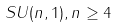Convert formula to latex. <formula><loc_0><loc_0><loc_500><loc_500>S U ( n , 1 ) , n \geq 4</formula> 